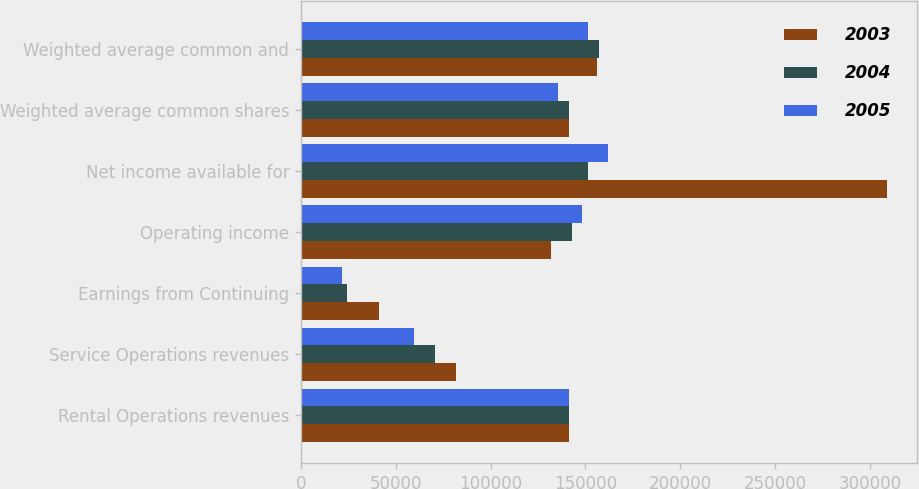Convert chart. <chart><loc_0><loc_0><loc_500><loc_500><stacked_bar_chart><ecel><fcel>Rental Operations revenues<fcel>Service Operations revenues<fcel>Earnings from Continuing<fcel>Operating income<fcel>Net income available for<fcel>Weighted average common shares<fcel>Weighted average common and<nl><fcel>2003<fcel>141508<fcel>81941<fcel>41019<fcel>131731<fcel>309183<fcel>141508<fcel>155877<nl><fcel>2004<fcel>141508<fcel>70803<fcel>24421<fcel>142856<fcel>151279<fcel>141379<fcel>157062<nl><fcel>2005<fcel>141508<fcel>59456<fcel>21821<fcel>148319<fcel>161911<fcel>135595<fcel>151141<nl></chart> 